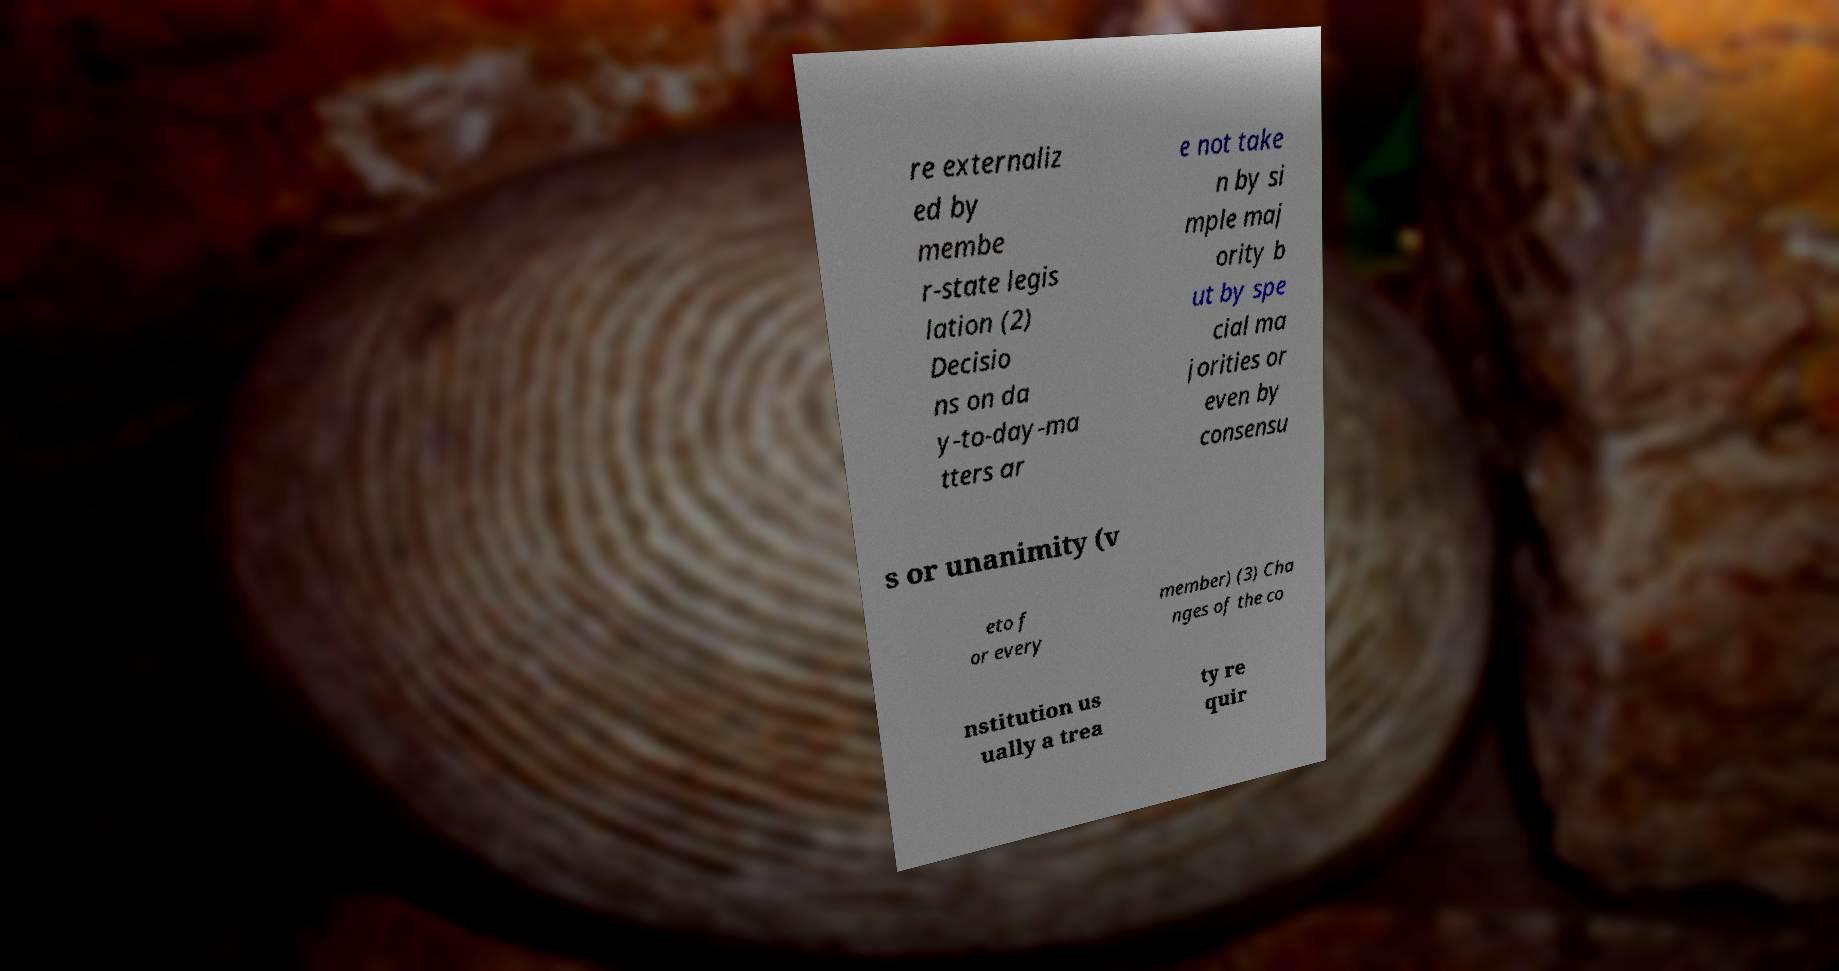Please read and relay the text visible in this image. What does it say? re externaliz ed by membe r-state legis lation (2) Decisio ns on da y-to-day-ma tters ar e not take n by si mple maj ority b ut by spe cial ma jorities or even by consensu s or unanimity (v eto f or every member) (3) Cha nges of the co nstitution us ually a trea ty re quir 